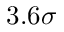Convert formula to latex. <formula><loc_0><loc_0><loc_500><loc_500>3 . 6 \sigma</formula> 